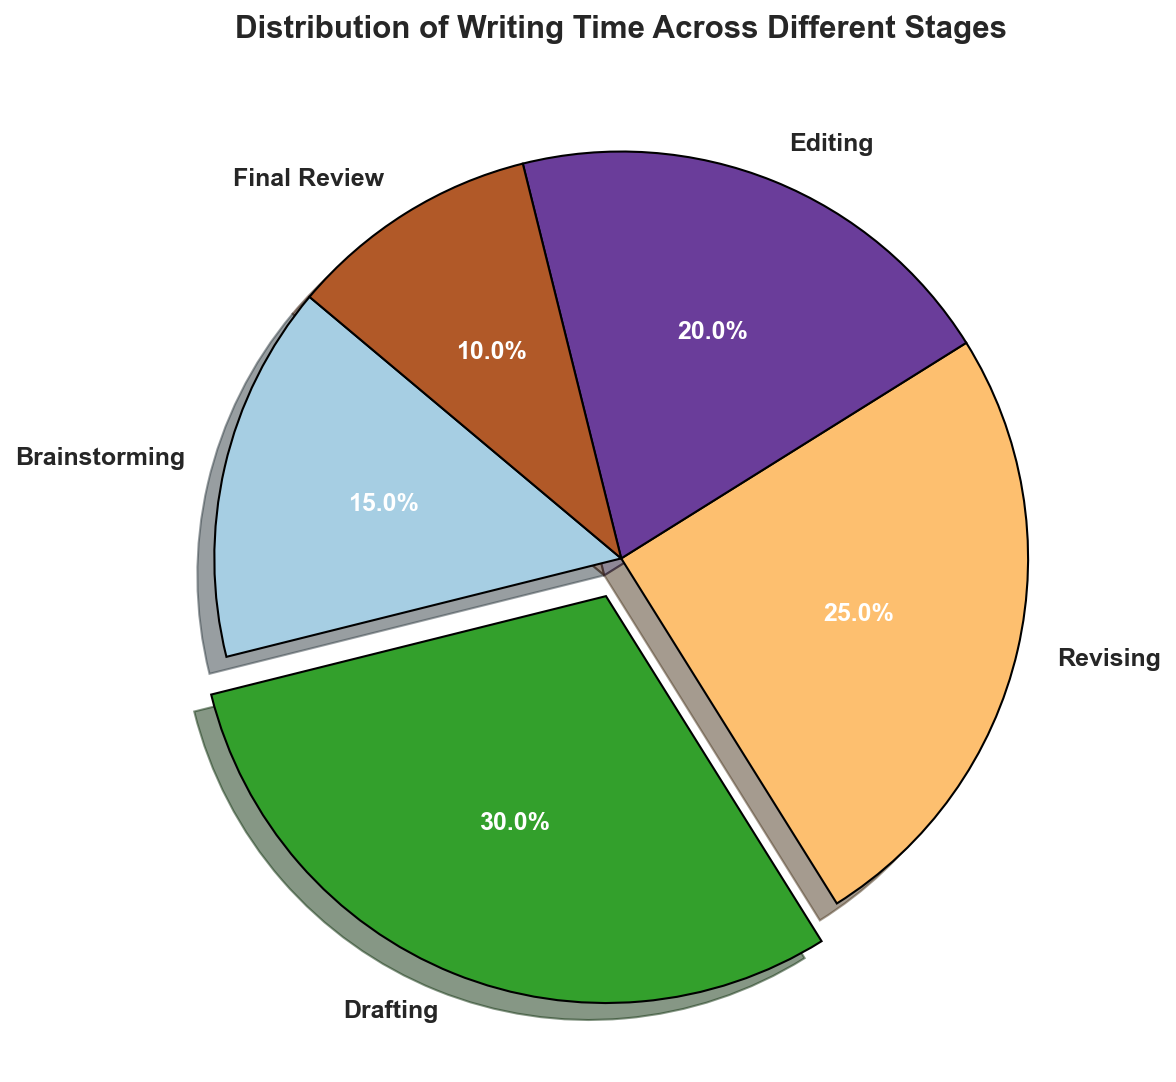Which stage takes up the most time? The 'Drafting' stage takes up the most time as its pie segment is the largest and is also exploded out from the rest.
Answer: Drafting Which two stages together take up the same amount of time as drafting alone? The 'Revising' and 'Editing' stages together take up (25% + 20%) = 45%, which is greater than 'Drafting' at 30%. The 'Brainstorming' and 'Final Review' stages together take up (15% + 10%) = 25%, which is less. Therefore, no two stages together take up exactly 30%, but based on the options considered, 'Brainstorming' and 'Editing' comes closest at (15% + 20%) = 35%.
Answer: None exactly, but closest is Brainstorming and Editing totaling 35% How much more time is spent revising compared to brainstorming? The time spent revising is 25% and the time spent brainstorming is 15%. The difference between these two is 25% - 15% = 10%.
Answer: 10% Is the time spent on the final review stage less than or equal to that of the brainstorming stage? The time spent on the final review stage is 10%, while the time spent on the brainstorming stage is 15%. Since 10% < 15%, the answer is yes, it's less.
Answer: Yes What is the total time spent on the stages before the final review? The stages before the final review are 'Brainstorming', 'Drafting', 'Revising', and 'Editing'. Their time spent are 15% + 30% + 25% + 20% = 90%.
Answer: 90% Which two stages have the same sum of percentages as the editing stage? The 'Brainstorming' and 'Final Review' stages together equal 15% + 10% = 25%, which is the same as the 'Revising' stage.
Answer: Brainstorming and Final Review What fraction of the total time is spent on editing compared to revising? The time spent on editing is 20% and the time spent on revising is 25%. The fraction is 20% / 25% which simplifies to 4/5 or 0.8.
Answer: 0.8 Which stage has a smaller percentage than both revising and drafting but larger than final review? Editing has 20%, which is smaller than Revising's 25% and Drafting's 30%, but larger than Final Review's 10%.
Answer: Editing 